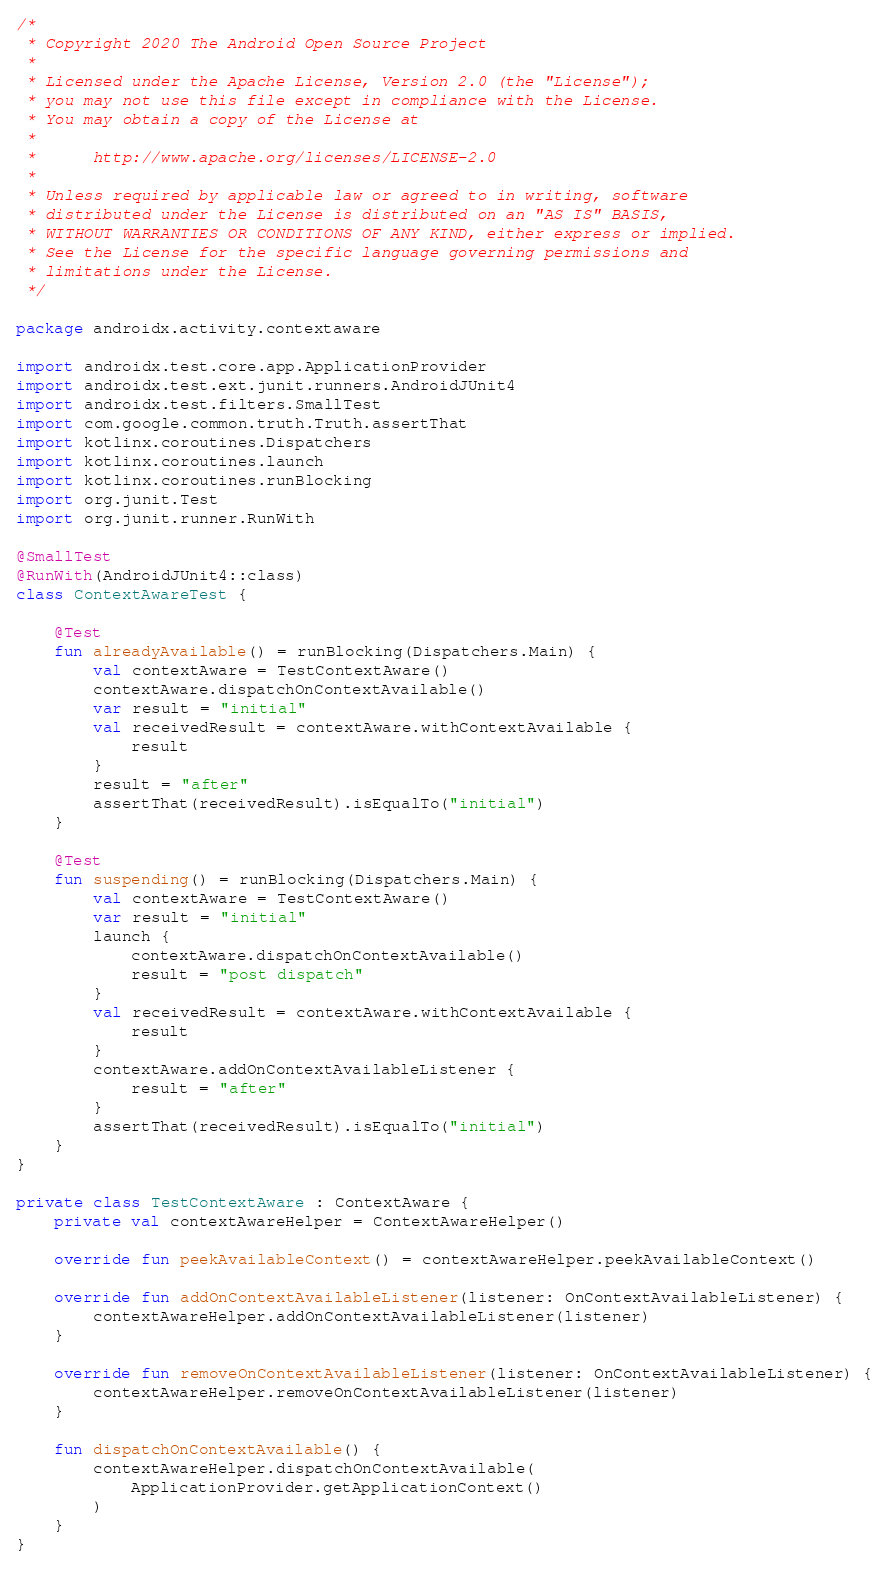Convert code to text. <code><loc_0><loc_0><loc_500><loc_500><_Kotlin_>/*
 * Copyright 2020 The Android Open Source Project
 *
 * Licensed under the Apache License, Version 2.0 (the "License");
 * you may not use this file except in compliance with the License.
 * You may obtain a copy of the License at
 *
 *      http://www.apache.org/licenses/LICENSE-2.0
 *
 * Unless required by applicable law or agreed to in writing, software
 * distributed under the License is distributed on an "AS IS" BASIS,
 * WITHOUT WARRANTIES OR CONDITIONS OF ANY KIND, either express or implied.
 * See the License for the specific language governing permissions and
 * limitations under the License.
 */

package androidx.activity.contextaware

import androidx.test.core.app.ApplicationProvider
import androidx.test.ext.junit.runners.AndroidJUnit4
import androidx.test.filters.SmallTest
import com.google.common.truth.Truth.assertThat
import kotlinx.coroutines.Dispatchers
import kotlinx.coroutines.launch
import kotlinx.coroutines.runBlocking
import org.junit.Test
import org.junit.runner.RunWith

@SmallTest
@RunWith(AndroidJUnit4::class)
class ContextAwareTest {

    @Test
    fun alreadyAvailable() = runBlocking(Dispatchers.Main) {
        val contextAware = TestContextAware()
        contextAware.dispatchOnContextAvailable()
        var result = "initial"
        val receivedResult = contextAware.withContextAvailable {
            result
        }
        result = "after"
        assertThat(receivedResult).isEqualTo("initial")
    }

    @Test
    fun suspending() = runBlocking(Dispatchers.Main) {
        val contextAware = TestContextAware()
        var result = "initial"
        launch {
            contextAware.dispatchOnContextAvailable()
            result = "post dispatch"
        }
        val receivedResult = contextAware.withContextAvailable {
            result
        }
        contextAware.addOnContextAvailableListener {
            result = "after"
        }
        assertThat(receivedResult).isEqualTo("initial")
    }
}

private class TestContextAware : ContextAware {
    private val contextAwareHelper = ContextAwareHelper()

    override fun peekAvailableContext() = contextAwareHelper.peekAvailableContext()

    override fun addOnContextAvailableListener(listener: OnContextAvailableListener) {
        contextAwareHelper.addOnContextAvailableListener(listener)
    }

    override fun removeOnContextAvailableListener(listener: OnContextAvailableListener) {
        contextAwareHelper.removeOnContextAvailableListener(listener)
    }

    fun dispatchOnContextAvailable() {
        contextAwareHelper.dispatchOnContextAvailable(
            ApplicationProvider.getApplicationContext()
        )
    }
}
</code> 